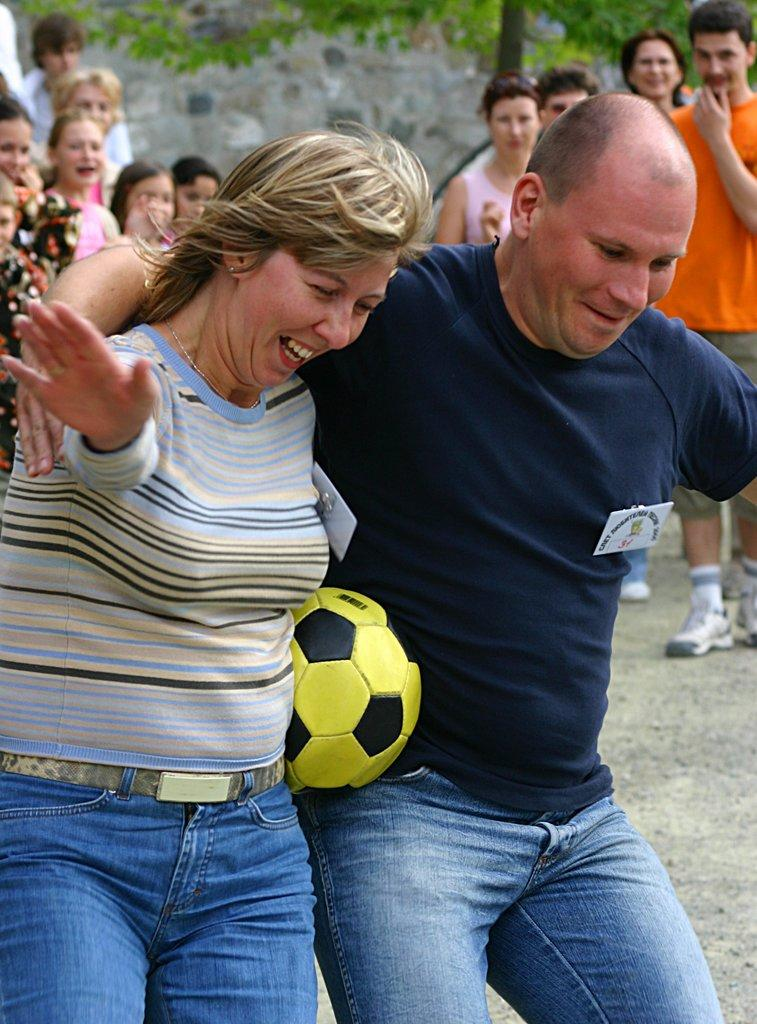How many people are present in the image? There are two people in the image, a man and a woman. What are the man and woman holding in the image? Both the man and woman are holding a football with their bodies. Can you describe the position of the people in the image? There are people standing on their backs. What type of sweater is the man wearing in the image? There is no sweater mentioned or visible in the image. What is the purpose of the army in the image? There is no army present in the image. 